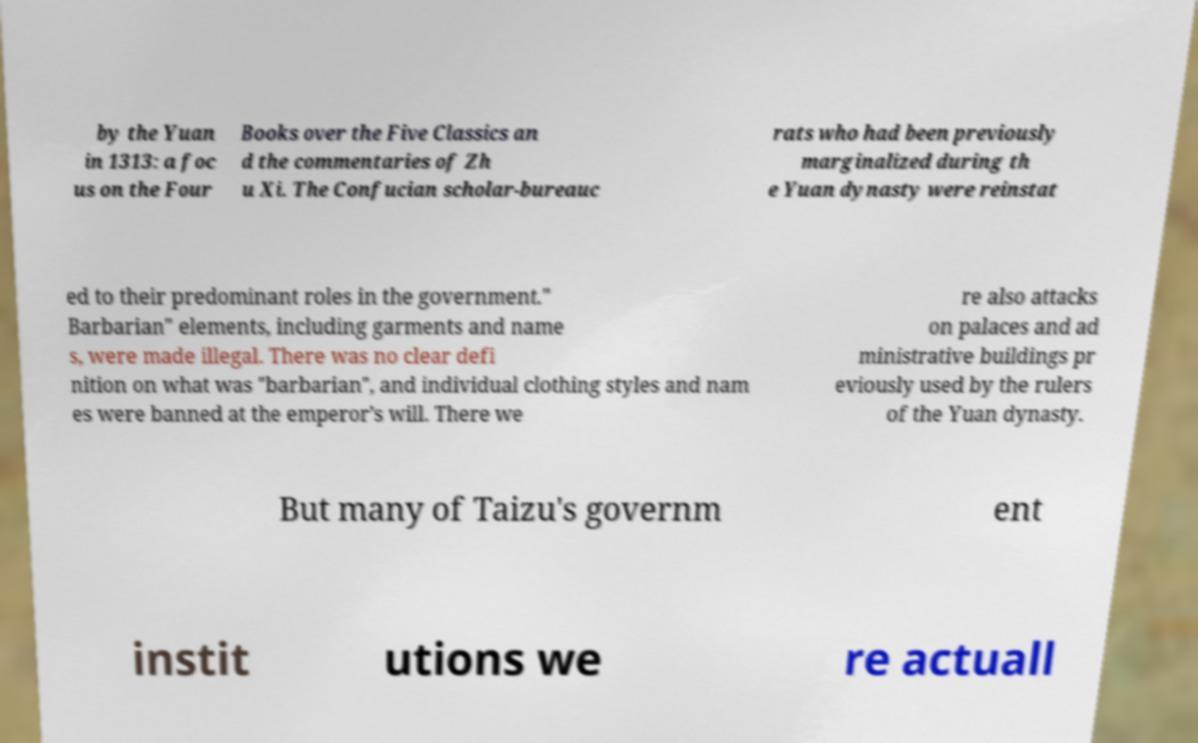What messages or text are displayed in this image? I need them in a readable, typed format. by the Yuan in 1313: a foc us on the Four Books over the Five Classics an d the commentaries of Zh u Xi. The Confucian scholar-bureauc rats who had been previously marginalized during th e Yuan dynasty were reinstat ed to their predominant roles in the government." Barbarian" elements, including garments and name s, were made illegal. There was no clear defi nition on what was "barbarian", and individual clothing styles and nam es were banned at the emperor’s will. There we re also attacks on palaces and ad ministrative buildings pr eviously used by the rulers of the Yuan dynasty. But many of Taizu's governm ent instit utions we re actuall 